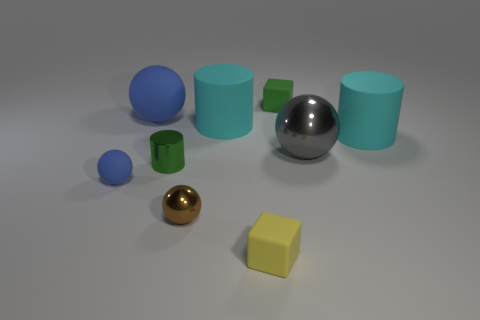Is there any other thing of the same color as the tiny cylinder?
Keep it short and to the point. Yes. Are there the same number of matte objects to the right of the green block and red cylinders?
Make the answer very short. No. How many metallic cylinders are in front of the block behind the large sphere that is left of the brown object?
Ensure brevity in your answer.  1. Is there a metal block of the same size as the metal cylinder?
Give a very brief answer. No. Are there fewer small yellow cubes that are behind the big blue rubber ball than things?
Your answer should be very brief. Yes. What is the material of the green thing that is to the left of the rubber block that is behind the cyan matte cylinder that is left of the yellow rubber object?
Keep it short and to the point. Metal. Are there more large cyan matte cylinders in front of the green block than large rubber balls that are left of the tiny yellow thing?
Provide a short and direct response. Yes. How many shiny things are gray spheres or brown spheres?
Make the answer very short. 2. What shape is the matte thing that is the same color as the tiny cylinder?
Your answer should be compact. Cube. What is the big cyan object to the left of the big shiny thing made of?
Offer a very short reply. Rubber. 